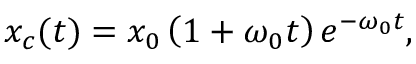Convert formula to latex. <formula><loc_0><loc_0><loc_500><loc_500>x _ { c } ( t ) = x _ { 0 } \left ( 1 + \omega _ { 0 } t \right ) e ^ { - \omega _ { 0 } t } ,</formula> 